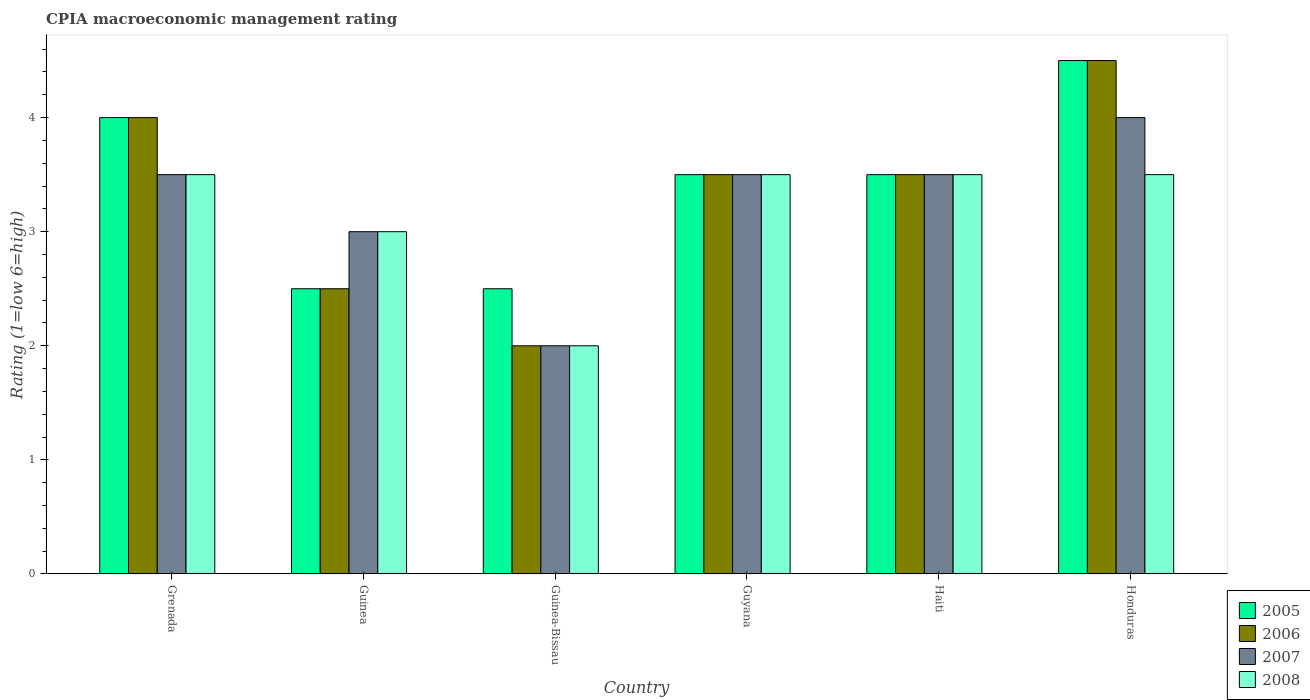How many groups of bars are there?
Your answer should be very brief. 6. Are the number of bars per tick equal to the number of legend labels?
Your answer should be very brief. Yes. Are the number of bars on each tick of the X-axis equal?
Make the answer very short. Yes. How many bars are there on the 4th tick from the right?
Offer a very short reply. 4. What is the label of the 5th group of bars from the left?
Provide a succinct answer. Haiti. In how many cases, is the number of bars for a given country not equal to the number of legend labels?
Provide a succinct answer. 0. What is the CPIA rating in 2006 in Haiti?
Keep it short and to the point. 3.5. Across all countries, what is the maximum CPIA rating in 2006?
Provide a succinct answer. 4.5. Across all countries, what is the minimum CPIA rating in 2006?
Provide a succinct answer. 2. In which country was the CPIA rating in 2005 maximum?
Your answer should be very brief. Honduras. In which country was the CPIA rating in 2006 minimum?
Make the answer very short. Guinea-Bissau. What is the total CPIA rating in 2008 in the graph?
Give a very brief answer. 19. What is the difference between the CPIA rating in 2008 in Guinea and that in Guyana?
Make the answer very short. -0.5. What is the average CPIA rating in 2006 per country?
Provide a short and direct response. 3.33. What is the ratio of the CPIA rating in 2005 in Guinea to that in Honduras?
Your answer should be compact. 0.56. Is the difference between the CPIA rating in 2008 in Guinea and Guinea-Bissau greater than the difference between the CPIA rating in 2007 in Guinea and Guinea-Bissau?
Your response must be concise. No. What is the difference between the highest and the second highest CPIA rating in 2006?
Keep it short and to the point. -1. What is the difference between the highest and the lowest CPIA rating in 2007?
Keep it short and to the point. 2. What does the 1st bar from the right in Haiti represents?
Ensure brevity in your answer.  2008. Is it the case that in every country, the sum of the CPIA rating in 2005 and CPIA rating in 2008 is greater than the CPIA rating in 2007?
Your answer should be very brief. Yes. What is the difference between two consecutive major ticks on the Y-axis?
Provide a succinct answer. 1. Are the values on the major ticks of Y-axis written in scientific E-notation?
Your response must be concise. No. Does the graph contain grids?
Provide a succinct answer. No. What is the title of the graph?
Your response must be concise. CPIA macroeconomic management rating. Does "1969" appear as one of the legend labels in the graph?
Make the answer very short. No. What is the label or title of the X-axis?
Give a very brief answer. Country. What is the Rating (1=low 6=high) in 2005 in Grenada?
Your response must be concise. 4. What is the Rating (1=low 6=high) of 2005 in Guinea-Bissau?
Keep it short and to the point. 2.5. What is the Rating (1=low 6=high) of 2008 in Guinea-Bissau?
Your response must be concise. 2. What is the Rating (1=low 6=high) in 2006 in Guyana?
Keep it short and to the point. 3.5. What is the Rating (1=low 6=high) in 2007 in Guyana?
Make the answer very short. 3.5. What is the Rating (1=low 6=high) of 2005 in Haiti?
Provide a succinct answer. 3.5. What is the Rating (1=low 6=high) of 2006 in Haiti?
Offer a very short reply. 3.5. What is the Rating (1=low 6=high) of 2007 in Haiti?
Your response must be concise. 3.5. What is the Rating (1=low 6=high) in 2008 in Haiti?
Ensure brevity in your answer.  3.5. What is the Rating (1=low 6=high) in 2005 in Honduras?
Make the answer very short. 4.5. What is the Rating (1=low 6=high) in 2007 in Honduras?
Your response must be concise. 4. Across all countries, what is the maximum Rating (1=low 6=high) in 2005?
Provide a succinct answer. 4.5. Across all countries, what is the maximum Rating (1=low 6=high) in 2007?
Your response must be concise. 4. Across all countries, what is the maximum Rating (1=low 6=high) in 2008?
Keep it short and to the point. 3.5. Across all countries, what is the minimum Rating (1=low 6=high) of 2005?
Your answer should be compact. 2.5. Across all countries, what is the minimum Rating (1=low 6=high) in 2007?
Your answer should be very brief. 2. What is the total Rating (1=low 6=high) of 2005 in the graph?
Make the answer very short. 20.5. What is the total Rating (1=low 6=high) of 2006 in the graph?
Provide a succinct answer. 20. What is the total Rating (1=low 6=high) in 2008 in the graph?
Give a very brief answer. 19. What is the difference between the Rating (1=low 6=high) of 2005 in Grenada and that in Guinea?
Give a very brief answer. 1.5. What is the difference between the Rating (1=low 6=high) of 2008 in Grenada and that in Guinea?
Provide a succinct answer. 0.5. What is the difference between the Rating (1=low 6=high) of 2006 in Grenada and that in Guinea-Bissau?
Make the answer very short. 2. What is the difference between the Rating (1=low 6=high) of 2008 in Grenada and that in Guinea-Bissau?
Your answer should be compact. 1.5. What is the difference between the Rating (1=low 6=high) in 2006 in Grenada and that in Guyana?
Your answer should be compact. 0.5. What is the difference between the Rating (1=low 6=high) in 2007 in Grenada and that in Guyana?
Your answer should be very brief. 0. What is the difference between the Rating (1=low 6=high) in 2006 in Grenada and that in Haiti?
Make the answer very short. 0.5. What is the difference between the Rating (1=low 6=high) in 2007 in Grenada and that in Haiti?
Provide a short and direct response. 0. What is the difference between the Rating (1=low 6=high) of 2005 in Grenada and that in Honduras?
Give a very brief answer. -0.5. What is the difference between the Rating (1=low 6=high) of 2008 in Grenada and that in Honduras?
Make the answer very short. 0. What is the difference between the Rating (1=low 6=high) in 2008 in Guinea and that in Guinea-Bissau?
Keep it short and to the point. 1. What is the difference between the Rating (1=low 6=high) in 2005 in Guinea and that in Guyana?
Ensure brevity in your answer.  -1. What is the difference between the Rating (1=low 6=high) of 2008 in Guinea and that in Guyana?
Make the answer very short. -0.5. What is the difference between the Rating (1=low 6=high) of 2006 in Guinea and that in Haiti?
Make the answer very short. -1. What is the difference between the Rating (1=low 6=high) of 2007 in Guinea and that in Haiti?
Make the answer very short. -0.5. What is the difference between the Rating (1=low 6=high) of 2006 in Guinea and that in Honduras?
Ensure brevity in your answer.  -2. What is the difference between the Rating (1=low 6=high) of 2005 in Guinea-Bissau and that in Guyana?
Offer a terse response. -1. What is the difference between the Rating (1=low 6=high) of 2006 in Guinea-Bissau and that in Guyana?
Ensure brevity in your answer.  -1.5. What is the difference between the Rating (1=low 6=high) of 2008 in Guinea-Bissau and that in Guyana?
Offer a very short reply. -1.5. What is the difference between the Rating (1=low 6=high) of 2005 in Guinea-Bissau and that in Haiti?
Keep it short and to the point. -1. What is the difference between the Rating (1=low 6=high) in 2006 in Guinea-Bissau and that in Haiti?
Offer a very short reply. -1.5. What is the difference between the Rating (1=low 6=high) in 2008 in Guinea-Bissau and that in Haiti?
Keep it short and to the point. -1.5. What is the difference between the Rating (1=low 6=high) of 2005 in Guinea-Bissau and that in Honduras?
Give a very brief answer. -2. What is the difference between the Rating (1=low 6=high) in 2006 in Guinea-Bissau and that in Honduras?
Your answer should be very brief. -2.5. What is the difference between the Rating (1=low 6=high) of 2007 in Guinea-Bissau and that in Honduras?
Your answer should be very brief. -2. What is the difference between the Rating (1=low 6=high) in 2008 in Guinea-Bissau and that in Honduras?
Offer a terse response. -1.5. What is the difference between the Rating (1=low 6=high) of 2005 in Guyana and that in Haiti?
Make the answer very short. 0. What is the difference between the Rating (1=low 6=high) of 2006 in Guyana and that in Haiti?
Make the answer very short. 0. What is the difference between the Rating (1=low 6=high) of 2008 in Guyana and that in Haiti?
Your response must be concise. 0. What is the difference between the Rating (1=low 6=high) in 2005 in Guyana and that in Honduras?
Offer a very short reply. -1. What is the difference between the Rating (1=low 6=high) of 2006 in Guyana and that in Honduras?
Give a very brief answer. -1. What is the difference between the Rating (1=low 6=high) of 2008 in Guyana and that in Honduras?
Make the answer very short. 0. What is the difference between the Rating (1=low 6=high) of 2006 in Haiti and that in Honduras?
Your response must be concise. -1. What is the difference between the Rating (1=low 6=high) in 2007 in Haiti and that in Honduras?
Your answer should be compact. -0.5. What is the difference between the Rating (1=low 6=high) of 2008 in Haiti and that in Honduras?
Offer a terse response. 0. What is the difference between the Rating (1=low 6=high) of 2005 in Grenada and the Rating (1=low 6=high) of 2006 in Guinea?
Offer a terse response. 1.5. What is the difference between the Rating (1=low 6=high) in 2005 in Grenada and the Rating (1=low 6=high) in 2007 in Guinea?
Offer a very short reply. 1. What is the difference between the Rating (1=low 6=high) in 2006 in Grenada and the Rating (1=low 6=high) in 2007 in Guinea?
Keep it short and to the point. 1. What is the difference between the Rating (1=low 6=high) in 2007 in Grenada and the Rating (1=low 6=high) in 2008 in Guinea?
Provide a short and direct response. 0.5. What is the difference between the Rating (1=low 6=high) of 2005 in Grenada and the Rating (1=low 6=high) of 2007 in Guinea-Bissau?
Make the answer very short. 2. What is the difference between the Rating (1=low 6=high) of 2006 in Grenada and the Rating (1=low 6=high) of 2007 in Guinea-Bissau?
Your answer should be compact. 2. What is the difference between the Rating (1=low 6=high) in 2006 in Grenada and the Rating (1=low 6=high) in 2008 in Guinea-Bissau?
Your answer should be very brief. 2. What is the difference between the Rating (1=low 6=high) of 2005 in Grenada and the Rating (1=low 6=high) of 2006 in Guyana?
Your response must be concise. 0.5. What is the difference between the Rating (1=low 6=high) in 2005 in Grenada and the Rating (1=low 6=high) in 2008 in Guyana?
Give a very brief answer. 0.5. What is the difference between the Rating (1=low 6=high) in 2006 in Grenada and the Rating (1=low 6=high) in 2007 in Guyana?
Keep it short and to the point. 0.5. What is the difference between the Rating (1=low 6=high) in 2006 in Grenada and the Rating (1=low 6=high) in 2008 in Guyana?
Make the answer very short. 0.5. What is the difference between the Rating (1=low 6=high) of 2005 in Grenada and the Rating (1=low 6=high) of 2006 in Haiti?
Make the answer very short. 0.5. What is the difference between the Rating (1=low 6=high) of 2005 in Grenada and the Rating (1=low 6=high) of 2007 in Haiti?
Keep it short and to the point. 0.5. What is the difference between the Rating (1=low 6=high) of 2005 in Grenada and the Rating (1=low 6=high) of 2008 in Haiti?
Provide a short and direct response. 0.5. What is the difference between the Rating (1=low 6=high) of 2006 in Grenada and the Rating (1=low 6=high) of 2007 in Haiti?
Make the answer very short. 0.5. What is the difference between the Rating (1=low 6=high) in 2007 in Grenada and the Rating (1=low 6=high) in 2008 in Haiti?
Make the answer very short. 0. What is the difference between the Rating (1=low 6=high) of 2005 in Grenada and the Rating (1=low 6=high) of 2007 in Honduras?
Offer a terse response. 0. What is the difference between the Rating (1=low 6=high) of 2006 in Grenada and the Rating (1=low 6=high) of 2007 in Honduras?
Ensure brevity in your answer.  0. What is the difference between the Rating (1=low 6=high) of 2006 in Guinea and the Rating (1=low 6=high) of 2008 in Guinea-Bissau?
Keep it short and to the point. 0.5. What is the difference between the Rating (1=low 6=high) in 2007 in Guinea and the Rating (1=low 6=high) in 2008 in Guinea-Bissau?
Give a very brief answer. 1. What is the difference between the Rating (1=low 6=high) of 2005 in Guinea and the Rating (1=low 6=high) of 2006 in Guyana?
Your answer should be very brief. -1. What is the difference between the Rating (1=low 6=high) of 2005 in Guinea and the Rating (1=low 6=high) of 2008 in Guyana?
Provide a short and direct response. -1. What is the difference between the Rating (1=low 6=high) in 2006 in Guinea and the Rating (1=low 6=high) in 2007 in Guyana?
Your answer should be very brief. -1. What is the difference between the Rating (1=low 6=high) in 2007 in Guinea and the Rating (1=low 6=high) in 2008 in Guyana?
Offer a terse response. -0.5. What is the difference between the Rating (1=low 6=high) in 2005 in Guinea and the Rating (1=low 6=high) in 2006 in Haiti?
Provide a short and direct response. -1. What is the difference between the Rating (1=low 6=high) in 2005 in Guinea and the Rating (1=low 6=high) in 2008 in Haiti?
Your answer should be compact. -1. What is the difference between the Rating (1=low 6=high) of 2005 in Guinea and the Rating (1=low 6=high) of 2008 in Honduras?
Your answer should be compact. -1. What is the difference between the Rating (1=low 6=high) of 2006 in Guinea and the Rating (1=low 6=high) of 2007 in Honduras?
Offer a very short reply. -1.5. What is the difference between the Rating (1=low 6=high) of 2007 in Guinea and the Rating (1=low 6=high) of 2008 in Honduras?
Offer a terse response. -0.5. What is the difference between the Rating (1=low 6=high) in 2005 in Guinea-Bissau and the Rating (1=low 6=high) in 2006 in Guyana?
Your answer should be compact. -1. What is the difference between the Rating (1=low 6=high) in 2005 in Guinea-Bissau and the Rating (1=low 6=high) in 2008 in Guyana?
Your response must be concise. -1. What is the difference between the Rating (1=low 6=high) in 2007 in Guinea-Bissau and the Rating (1=low 6=high) in 2008 in Haiti?
Your answer should be compact. -1.5. What is the difference between the Rating (1=low 6=high) in 2005 in Guinea-Bissau and the Rating (1=low 6=high) in 2008 in Honduras?
Make the answer very short. -1. What is the difference between the Rating (1=low 6=high) in 2006 in Guinea-Bissau and the Rating (1=low 6=high) in 2008 in Honduras?
Your answer should be very brief. -1.5. What is the difference between the Rating (1=low 6=high) in 2007 in Guinea-Bissau and the Rating (1=low 6=high) in 2008 in Honduras?
Offer a very short reply. -1.5. What is the difference between the Rating (1=low 6=high) in 2005 in Guyana and the Rating (1=low 6=high) in 2006 in Haiti?
Your response must be concise. 0. What is the difference between the Rating (1=low 6=high) of 2006 in Guyana and the Rating (1=low 6=high) of 2007 in Haiti?
Your answer should be compact. 0. What is the difference between the Rating (1=low 6=high) in 2006 in Guyana and the Rating (1=low 6=high) in 2008 in Haiti?
Provide a succinct answer. 0. What is the difference between the Rating (1=low 6=high) of 2007 in Guyana and the Rating (1=low 6=high) of 2008 in Haiti?
Make the answer very short. 0. What is the difference between the Rating (1=low 6=high) in 2005 in Haiti and the Rating (1=low 6=high) in 2007 in Honduras?
Offer a very short reply. -0.5. What is the difference between the Rating (1=low 6=high) of 2005 in Haiti and the Rating (1=low 6=high) of 2008 in Honduras?
Offer a very short reply. 0. What is the difference between the Rating (1=low 6=high) in 2006 in Haiti and the Rating (1=low 6=high) in 2008 in Honduras?
Provide a short and direct response. 0. What is the difference between the Rating (1=low 6=high) of 2007 in Haiti and the Rating (1=low 6=high) of 2008 in Honduras?
Your answer should be very brief. 0. What is the average Rating (1=low 6=high) of 2005 per country?
Your response must be concise. 3.42. What is the average Rating (1=low 6=high) in 2007 per country?
Offer a terse response. 3.25. What is the average Rating (1=low 6=high) in 2008 per country?
Provide a short and direct response. 3.17. What is the difference between the Rating (1=low 6=high) of 2005 and Rating (1=low 6=high) of 2006 in Grenada?
Offer a very short reply. 0. What is the difference between the Rating (1=low 6=high) in 2005 and Rating (1=low 6=high) in 2007 in Grenada?
Your answer should be compact. 0.5. What is the difference between the Rating (1=low 6=high) of 2005 and Rating (1=low 6=high) of 2008 in Grenada?
Provide a short and direct response. 0.5. What is the difference between the Rating (1=low 6=high) in 2006 and Rating (1=low 6=high) in 2007 in Grenada?
Give a very brief answer. 0.5. What is the difference between the Rating (1=low 6=high) of 2006 and Rating (1=low 6=high) of 2008 in Grenada?
Offer a terse response. 0.5. What is the difference between the Rating (1=low 6=high) of 2005 and Rating (1=low 6=high) of 2006 in Guinea?
Provide a succinct answer. 0. What is the difference between the Rating (1=low 6=high) in 2005 and Rating (1=low 6=high) in 2006 in Guinea-Bissau?
Offer a very short reply. 0.5. What is the difference between the Rating (1=low 6=high) in 2006 and Rating (1=low 6=high) in 2008 in Guinea-Bissau?
Your answer should be very brief. 0. What is the difference between the Rating (1=low 6=high) of 2005 and Rating (1=low 6=high) of 2006 in Guyana?
Keep it short and to the point. 0. What is the difference between the Rating (1=low 6=high) of 2005 and Rating (1=low 6=high) of 2008 in Guyana?
Keep it short and to the point. 0. What is the difference between the Rating (1=low 6=high) in 2006 and Rating (1=low 6=high) in 2008 in Guyana?
Your response must be concise. 0. What is the difference between the Rating (1=low 6=high) in 2007 and Rating (1=low 6=high) in 2008 in Guyana?
Give a very brief answer. 0. What is the difference between the Rating (1=low 6=high) in 2005 and Rating (1=low 6=high) in 2008 in Haiti?
Your answer should be compact. 0. What is the difference between the Rating (1=low 6=high) of 2006 and Rating (1=low 6=high) of 2007 in Haiti?
Provide a succinct answer. 0. What is the difference between the Rating (1=low 6=high) of 2005 and Rating (1=low 6=high) of 2008 in Honduras?
Offer a very short reply. 1. What is the difference between the Rating (1=low 6=high) in 2006 and Rating (1=low 6=high) in 2007 in Honduras?
Make the answer very short. 0.5. What is the difference between the Rating (1=low 6=high) of 2006 and Rating (1=low 6=high) of 2008 in Honduras?
Provide a short and direct response. 1. What is the ratio of the Rating (1=low 6=high) of 2005 in Grenada to that in Guinea-Bissau?
Offer a very short reply. 1.6. What is the ratio of the Rating (1=low 6=high) in 2006 in Grenada to that in Guinea-Bissau?
Offer a terse response. 2. What is the ratio of the Rating (1=low 6=high) in 2007 in Grenada to that in Guyana?
Ensure brevity in your answer.  1. What is the ratio of the Rating (1=low 6=high) of 2005 in Grenada to that in Haiti?
Give a very brief answer. 1.14. What is the ratio of the Rating (1=low 6=high) in 2007 in Grenada to that in Haiti?
Your response must be concise. 1. What is the ratio of the Rating (1=low 6=high) in 2008 in Grenada to that in Haiti?
Your answer should be compact. 1. What is the ratio of the Rating (1=low 6=high) in 2006 in Grenada to that in Honduras?
Offer a terse response. 0.89. What is the ratio of the Rating (1=low 6=high) of 2008 in Grenada to that in Honduras?
Provide a succinct answer. 1. What is the ratio of the Rating (1=low 6=high) of 2005 in Guinea to that in Guinea-Bissau?
Your answer should be compact. 1. What is the ratio of the Rating (1=low 6=high) of 2007 in Guinea to that in Guinea-Bissau?
Provide a succinct answer. 1.5. What is the ratio of the Rating (1=low 6=high) of 2007 in Guinea to that in Guyana?
Give a very brief answer. 0.86. What is the ratio of the Rating (1=low 6=high) of 2005 in Guinea to that in Haiti?
Keep it short and to the point. 0.71. What is the ratio of the Rating (1=low 6=high) in 2008 in Guinea to that in Haiti?
Your answer should be compact. 0.86. What is the ratio of the Rating (1=low 6=high) of 2005 in Guinea to that in Honduras?
Your answer should be very brief. 0.56. What is the ratio of the Rating (1=low 6=high) of 2006 in Guinea to that in Honduras?
Make the answer very short. 0.56. What is the ratio of the Rating (1=low 6=high) of 2007 in Guinea to that in Honduras?
Your answer should be very brief. 0.75. What is the ratio of the Rating (1=low 6=high) of 2005 in Guinea-Bissau to that in Guyana?
Your answer should be compact. 0.71. What is the ratio of the Rating (1=low 6=high) in 2006 in Guinea-Bissau to that in Guyana?
Your answer should be very brief. 0.57. What is the ratio of the Rating (1=low 6=high) in 2007 in Guinea-Bissau to that in Guyana?
Give a very brief answer. 0.57. What is the ratio of the Rating (1=low 6=high) of 2006 in Guinea-Bissau to that in Haiti?
Your answer should be very brief. 0.57. What is the ratio of the Rating (1=low 6=high) in 2007 in Guinea-Bissau to that in Haiti?
Your answer should be compact. 0.57. What is the ratio of the Rating (1=low 6=high) of 2008 in Guinea-Bissau to that in Haiti?
Make the answer very short. 0.57. What is the ratio of the Rating (1=low 6=high) of 2005 in Guinea-Bissau to that in Honduras?
Offer a terse response. 0.56. What is the ratio of the Rating (1=low 6=high) in 2006 in Guinea-Bissau to that in Honduras?
Your answer should be compact. 0.44. What is the ratio of the Rating (1=low 6=high) of 2007 in Guinea-Bissau to that in Honduras?
Offer a terse response. 0.5. What is the ratio of the Rating (1=low 6=high) in 2008 in Guinea-Bissau to that in Honduras?
Your answer should be very brief. 0.57. What is the ratio of the Rating (1=low 6=high) in 2008 in Guyana to that in Haiti?
Keep it short and to the point. 1. What is the ratio of the Rating (1=low 6=high) in 2007 in Guyana to that in Honduras?
Give a very brief answer. 0.88. What is the ratio of the Rating (1=low 6=high) in 2006 in Haiti to that in Honduras?
Your answer should be compact. 0.78. What is the ratio of the Rating (1=low 6=high) in 2008 in Haiti to that in Honduras?
Ensure brevity in your answer.  1. What is the difference between the highest and the second highest Rating (1=low 6=high) of 2007?
Your answer should be compact. 0.5. What is the difference between the highest and the lowest Rating (1=low 6=high) in 2005?
Your answer should be very brief. 2. What is the difference between the highest and the lowest Rating (1=low 6=high) of 2007?
Give a very brief answer. 2. 